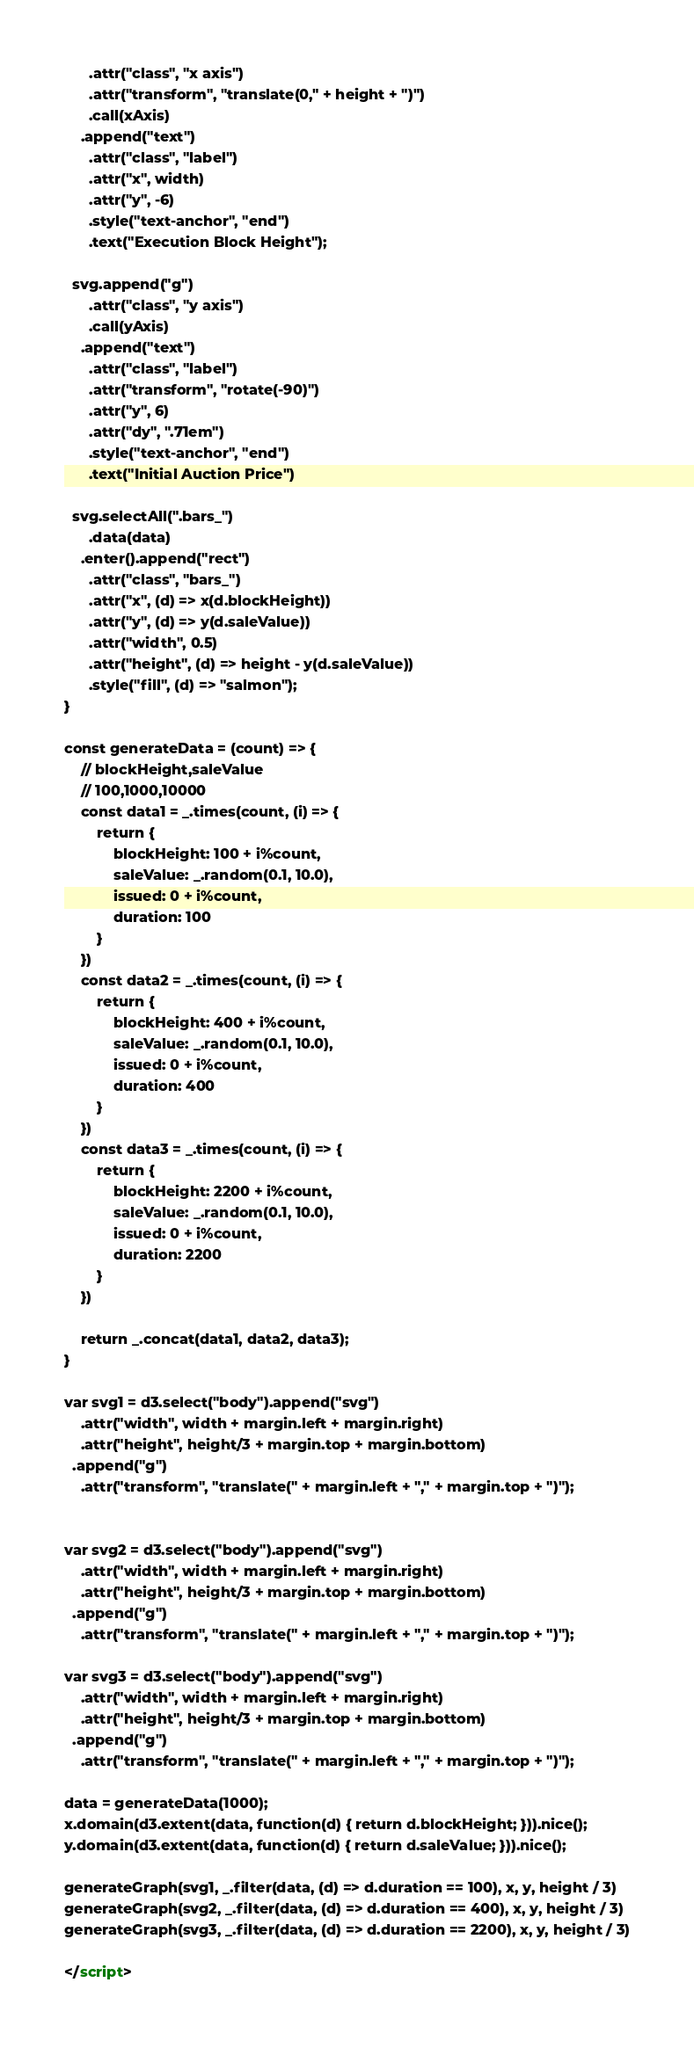Convert code to text. <code><loc_0><loc_0><loc_500><loc_500><_HTML_>      .attr("class", "x axis")
      .attr("transform", "translate(0," + height + ")")
      .call(xAxis)
    .append("text")
      .attr("class", "label")
      .attr("x", width)
      .attr("y", -6)
      .style("text-anchor", "end")
      .text("Execution Block Height");

  svg.append("g")
      .attr("class", "y axis")
      .call(yAxis)
    .append("text")
      .attr("class", "label")
      .attr("transform", "rotate(-90)")
      .attr("y", 6)
      .attr("dy", ".71em")
      .style("text-anchor", "end")
      .text("Initial Auction Price")

  svg.selectAll(".bars_")
      .data(data)
    .enter().append("rect")
      .attr("class", "bars_")
      .attr("x", (d) => x(d.blockHeight))
      .attr("y", (d) => y(d.saleValue))
      .attr("width", 0.5)
      .attr("height", (d) => height - y(d.saleValue))
      .style("fill", (d) => "salmon");
}

const generateData = (count) => {
	// blockHeight,saleValue
	// 100,1000,10000
	const data1 = _.times(count, (i) => {
		return {
			blockHeight: 100 + i%count,
			saleValue: _.random(0.1, 10.0),
			issued: 0 + i%count,
			duration: 100
		}
	})
	const data2 = _.times(count, (i) => {
		return {
			blockHeight: 400 + i%count,
			saleValue: _.random(0.1, 10.0),
			issued: 0 + i%count,
			duration: 400
		}
	})
	const data3 = _.times(count, (i) => {
		return {
			blockHeight: 2200 + i%count,
			saleValue: _.random(0.1, 10.0),
			issued: 0 + i%count,
			duration: 2200
		}
	})

	return _.concat(data1, data2, data3);
}

var svg1 = d3.select("body").append("svg")
    .attr("width", width + margin.left + margin.right)
    .attr("height", height/3 + margin.top + margin.bottom)
  .append("g")
    .attr("transform", "translate(" + margin.left + "," + margin.top + ")");


var svg2 = d3.select("body").append("svg")
    .attr("width", width + margin.left + margin.right)
    .attr("height", height/3 + margin.top + margin.bottom)
  .append("g")
    .attr("transform", "translate(" + margin.left + "," + margin.top + ")");

var svg3 = d3.select("body").append("svg")
    .attr("width", width + margin.left + margin.right)
    .attr("height", height/3 + margin.top + margin.bottom)
  .append("g")
    .attr("transform", "translate(" + margin.left + "," + margin.top + ")");

data = generateData(1000);
x.domain(d3.extent(data, function(d) { return d.blockHeight; })).nice();
y.domain(d3.extent(data, function(d) { return d.saleValue; })).nice();

generateGraph(svg1, _.filter(data, (d) => d.duration == 100), x, y, height / 3)
generateGraph(svg2, _.filter(data, (d) => d.duration == 400), x, y, height / 3)
generateGraph(svg3, _.filter(data, (d) => d.duration == 2200), x, y, height / 3)

</script></code> 